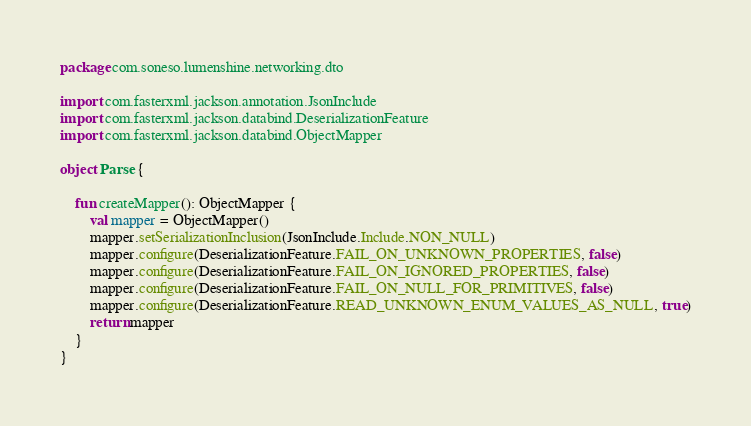<code> <loc_0><loc_0><loc_500><loc_500><_Kotlin_>package com.soneso.lumenshine.networking.dto

import com.fasterxml.jackson.annotation.JsonInclude
import com.fasterxml.jackson.databind.DeserializationFeature
import com.fasterxml.jackson.databind.ObjectMapper

object Parse {

    fun createMapper(): ObjectMapper {
        val mapper = ObjectMapper()
        mapper.setSerializationInclusion(JsonInclude.Include.NON_NULL)
        mapper.configure(DeserializationFeature.FAIL_ON_UNKNOWN_PROPERTIES, false)
        mapper.configure(DeserializationFeature.FAIL_ON_IGNORED_PROPERTIES, false)
        mapper.configure(DeserializationFeature.FAIL_ON_NULL_FOR_PRIMITIVES, false)
        mapper.configure(DeserializationFeature.READ_UNKNOWN_ENUM_VALUES_AS_NULL, true)
        return mapper
    }
}</code> 